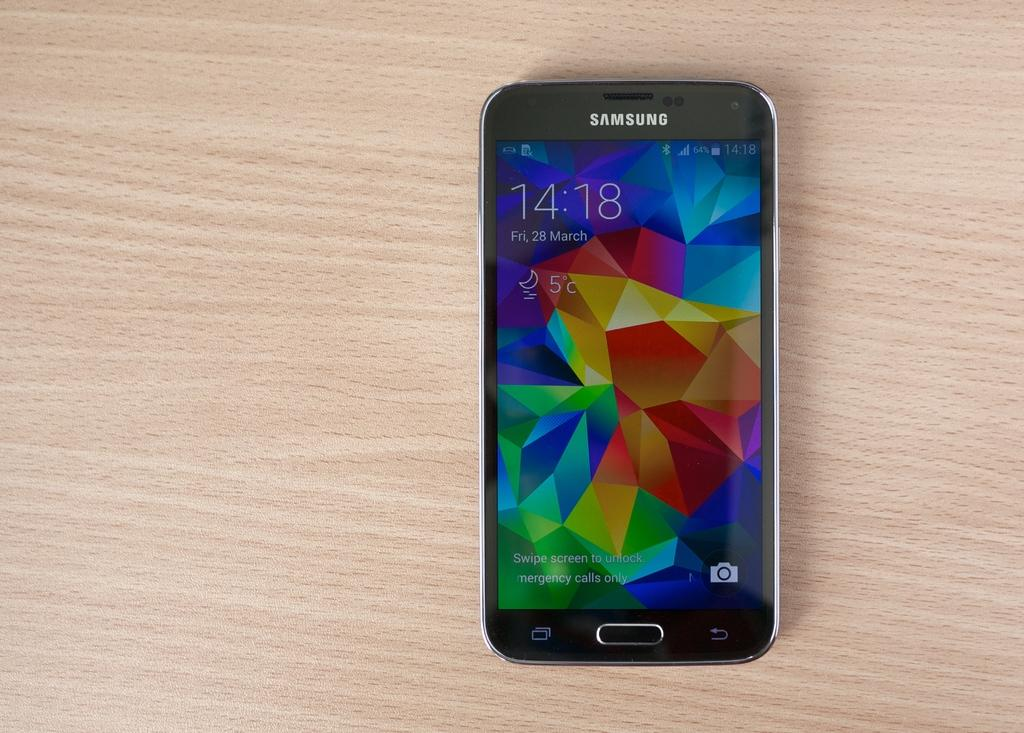<image>
Relay a brief, clear account of the picture shown. A samsung mobile device sitting on a lightly colored wooden table at 14:18 on March 28. 